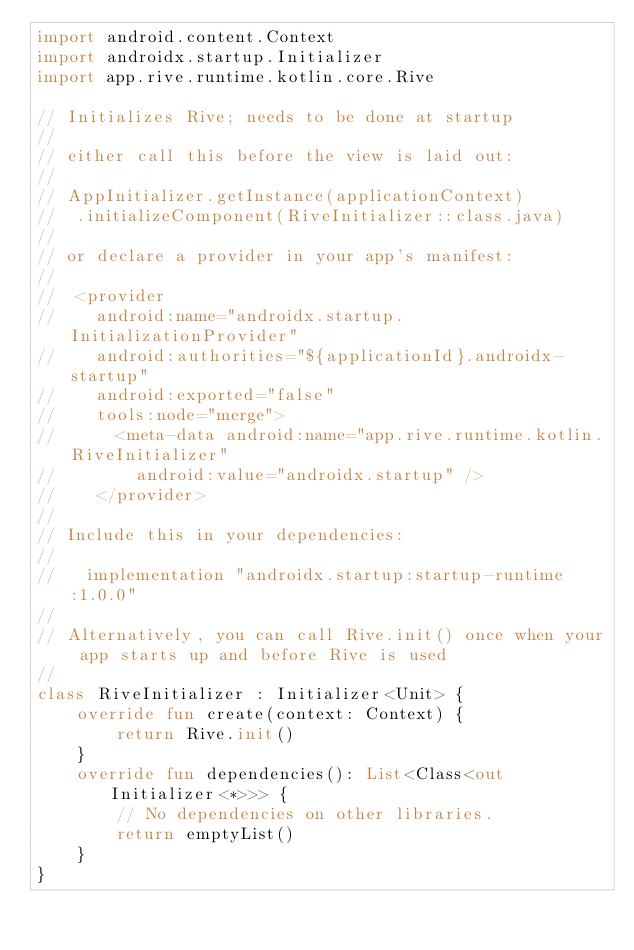<code> <loc_0><loc_0><loc_500><loc_500><_Kotlin_>import android.content.Context
import androidx.startup.Initializer
import app.rive.runtime.kotlin.core.Rive

// Initializes Rive; needs to be done at startup
//
// either call this before the view is laid out:
//
// AppInitializer.getInstance(applicationContext)
//  .initializeComponent(RiveInitializer::class.java)
//
// or declare a provider in your app's manifest:
//
//  <provider
//    android:name="androidx.startup.InitializationProvider"
//    android:authorities="${applicationId}.androidx-startup"
//    android:exported="false"
//    tools:node="merge">
//      <meta-data android:name="app.rive.runtime.kotlin.RiveInitializer"
//        android:value="androidx.startup" />
//    </provider>
//
// Include this in your dependencies:
//
//   implementation "androidx.startup:startup-runtime:1.0.0"
//
// Alternatively, you can call Rive.init() once when your app starts up and before Rive is used
//
class RiveInitializer : Initializer<Unit> {
    override fun create(context: Context) {
        return Rive.init()
    }
    override fun dependencies(): List<Class<out Initializer<*>>> {
        // No dependencies on other libraries.
        return emptyList()
    }
}</code> 